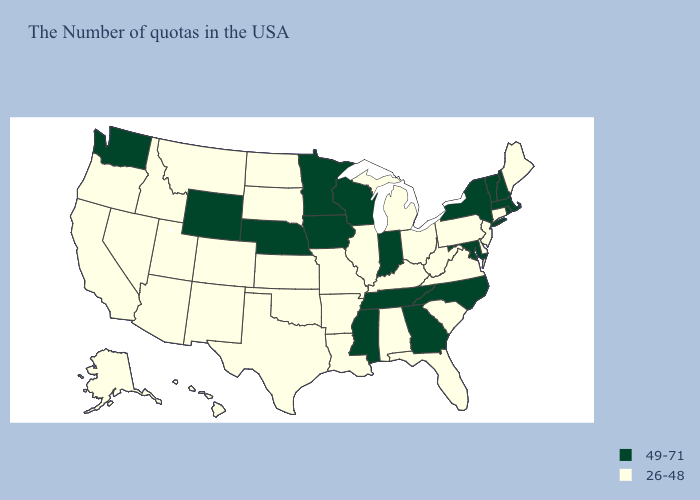Name the states that have a value in the range 49-71?
Keep it brief. Massachusetts, Rhode Island, New Hampshire, Vermont, New York, Maryland, North Carolina, Georgia, Indiana, Tennessee, Wisconsin, Mississippi, Minnesota, Iowa, Nebraska, Wyoming, Washington. What is the lowest value in the Northeast?
Concise answer only. 26-48. Name the states that have a value in the range 49-71?
Short answer required. Massachusetts, Rhode Island, New Hampshire, Vermont, New York, Maryland, North Carolina, Georgia, Indiana, Tennessee, Wisconsin, Mississippi, Minnesota, Iowa, Nebraska, Wyoming, Washington. Which states have the lowest value in the USA?
Answer briefly. Maine, Connecticut, New Jersey, Delaware, Pennsylvania, Virginia, South Carolina, West Virginia, Ohio, Florida, Michigan, Kentucky, Alabama, Illinois, Louisiana, Missouri, Arkansas, Kansas, Oklahoma, Texas, South Dakota, North Dakota, Colorado, New Mexico, Utah, Montana, Arizona, Idaho, Nevada, California, Oregon, Alaska, Hawaii. Name the states that have a value in the range 26-48?
Short answer required. Maine, Connecticut, New Jersey, Delaware, Pennsylvania, Virginia, South Carolina, West Virginia, Ohio, Florida, Michigan, Kentucky, Alabama, Illinois, Louisiana, Missouri, Arkansas, Kansas, Oklahoma, Texas, South Dakota, North Dakota, Colorado, New Mexico, Utah, Montana, Arizona, Idaho, Nevada, California, Oregon, Alaska, Hawaii. What is the lowest value in the Northeast?
Quick response, please. 26-48. Does New Mexico have the lowest value in the USA?
Answer briefly. Yes. Does the map have missing data?
Write a very short answer. No. What is the value of New Mexico?
Keep it brief. 26-48. Among the states that border New Jersey , which have the lowest value?
Answer briefly. Delaware, Pennsylvania. Name the states that have a value in the range 49-71?
Write a very short answer. Massachusetts, Rhode Island, New Hampshire, Vermont, New York, Maryland, North Carolina, Georgia, Indiana, Tennessee, Wisconsin, Mississippi, Minnesota, Iowa, Nebraska, Wyoming, Washington. Does New Hampshire have the lowest value in the USA?
Quick response, please. No. What is the value of Connecticut?
Be succinct. 26-48. Among the states that border Idaho , which have the highest value?
Short answer required. Wyoming, Washington. Which states hav the highest value in the West?
Answer briefly. Wyoming, Washington. 